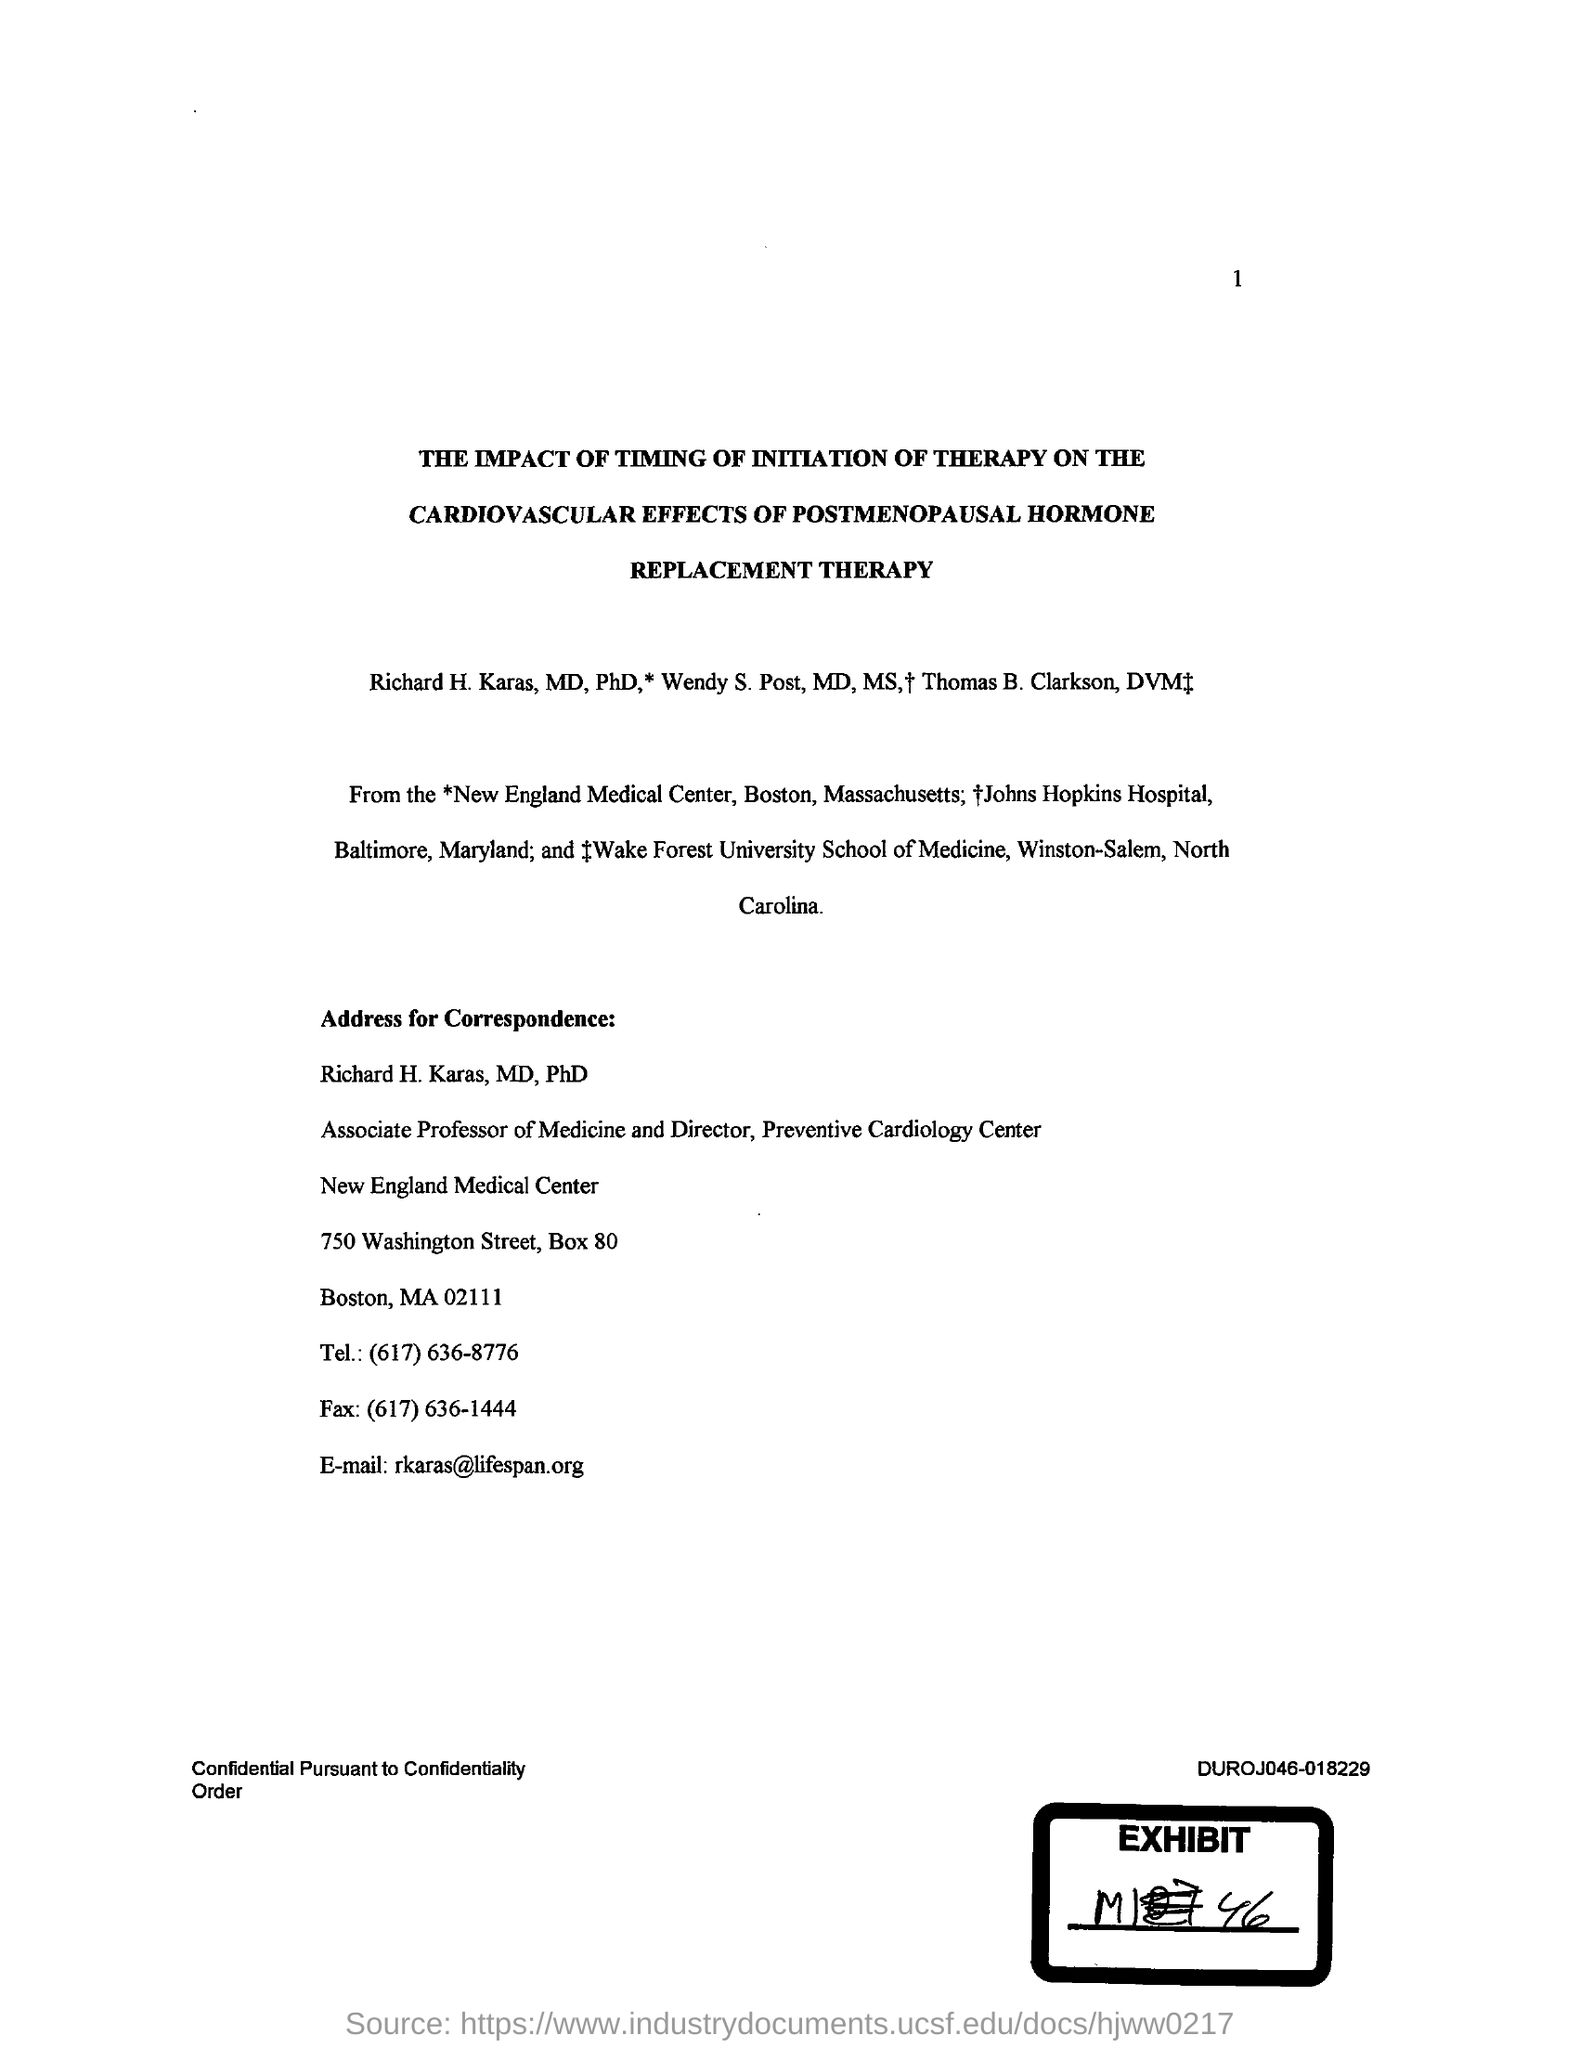Outline some significant characteristics in this image. I have been given the fax number (617) 636-1444. The email address provided is [lifespan.org](mailto:lifespan.org)@rkaras. The telephone number given is (617) 636-8776. 